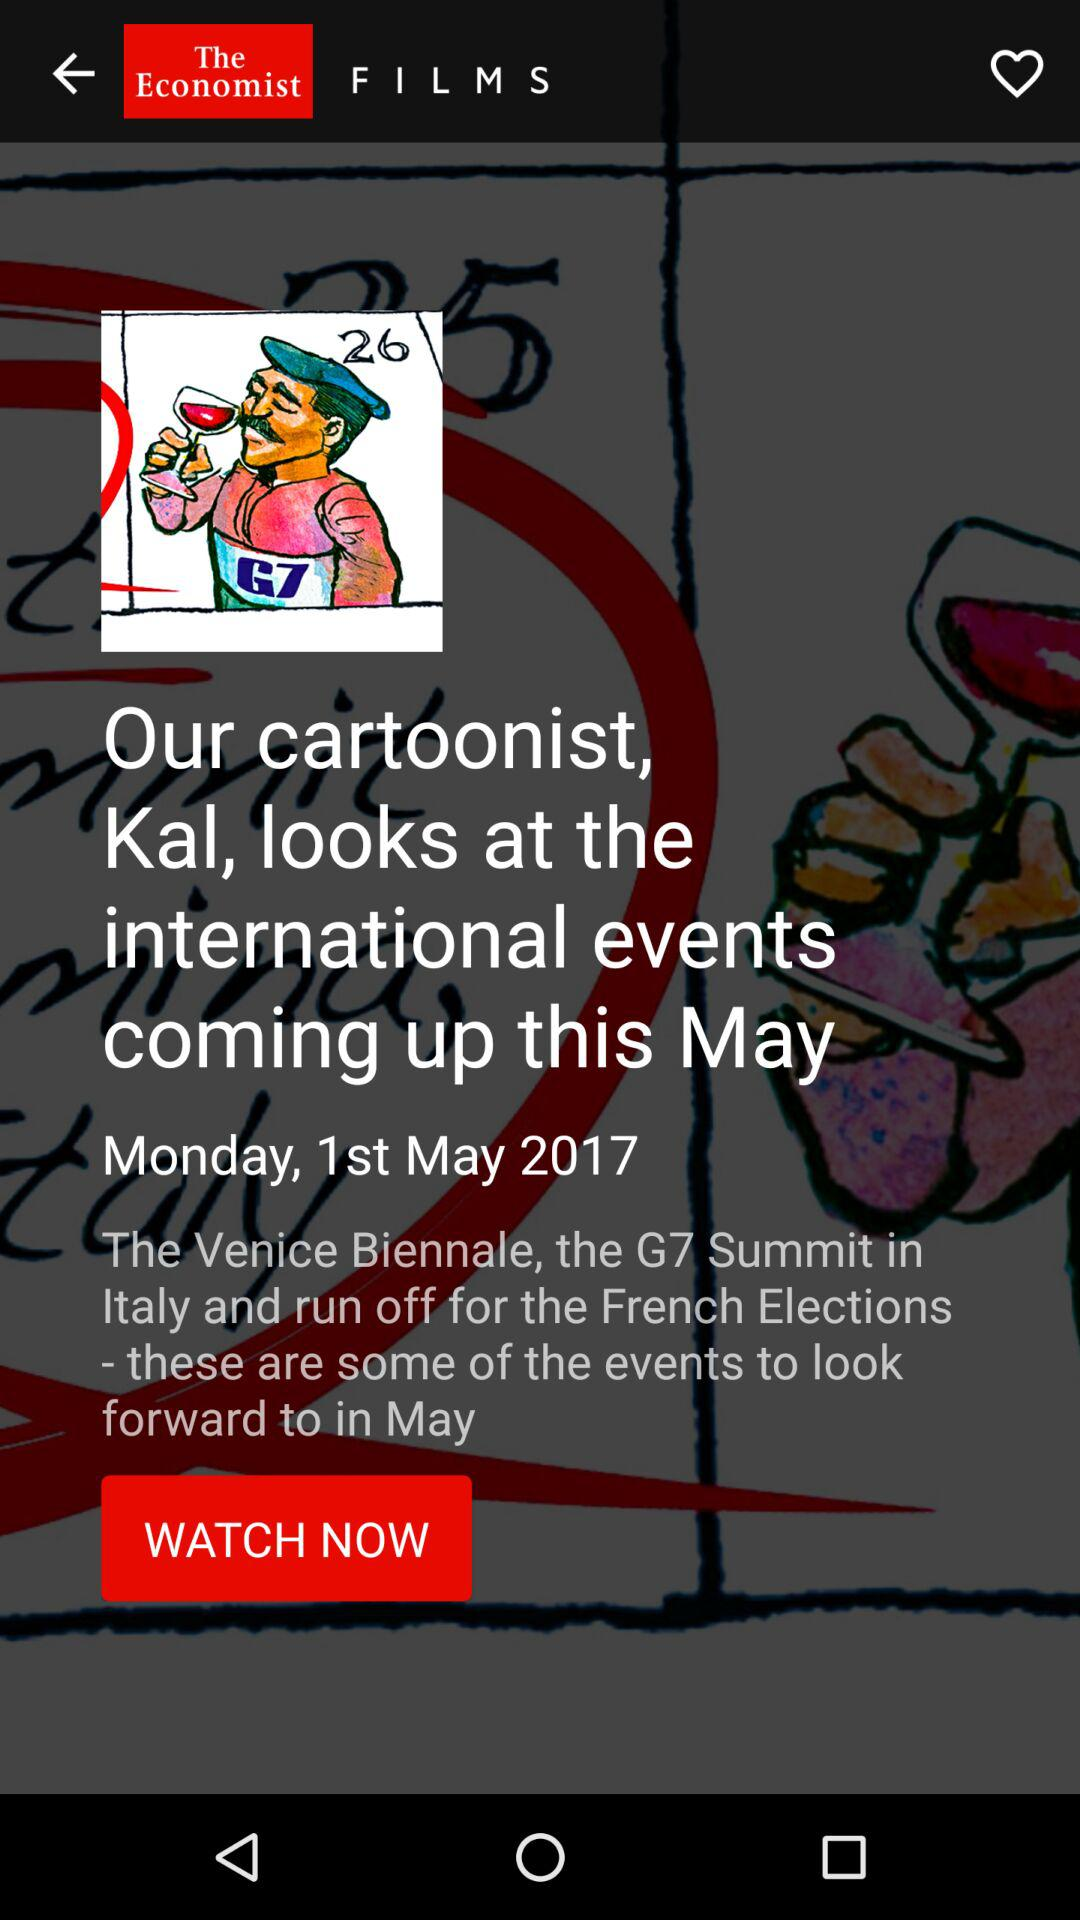Which date is displayed on the screen? The date is Monday, 1st May 2017. 